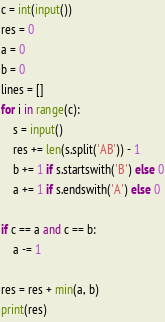Convert code to text. <code><loc_0><loc_0><loc_500><loc_500><_Python_>c = int(input())
res = 0
a = 0
b = 0
lines = []
for i in range(c):
    s = input()
    res += len(s.split('AB')) - 1
    b += 1 if s.startswith('B') else 0
    a += 1 if s.endswith('A') else 0

if c == a and c == b:
    a -= 1

res = res + min(a, b)
print(res)</code> 